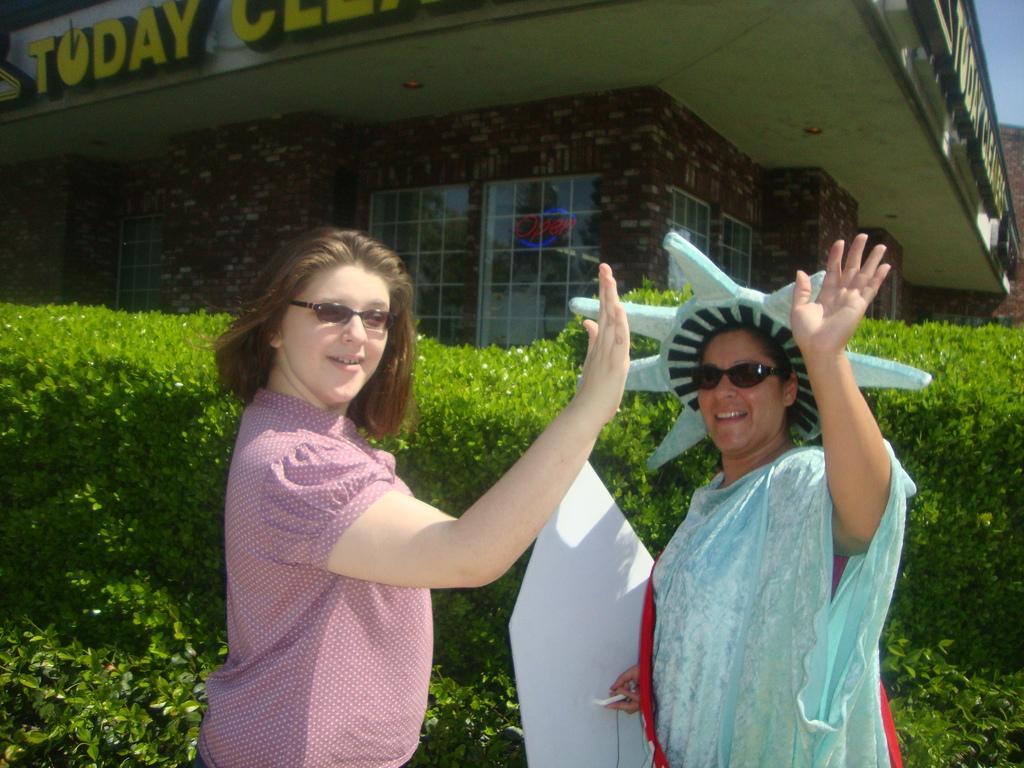Could you give a brief overview of what you see in this image? In the foreground of the picture we can see two women and plants. In the background we can see a building. At the top right it is sky. 